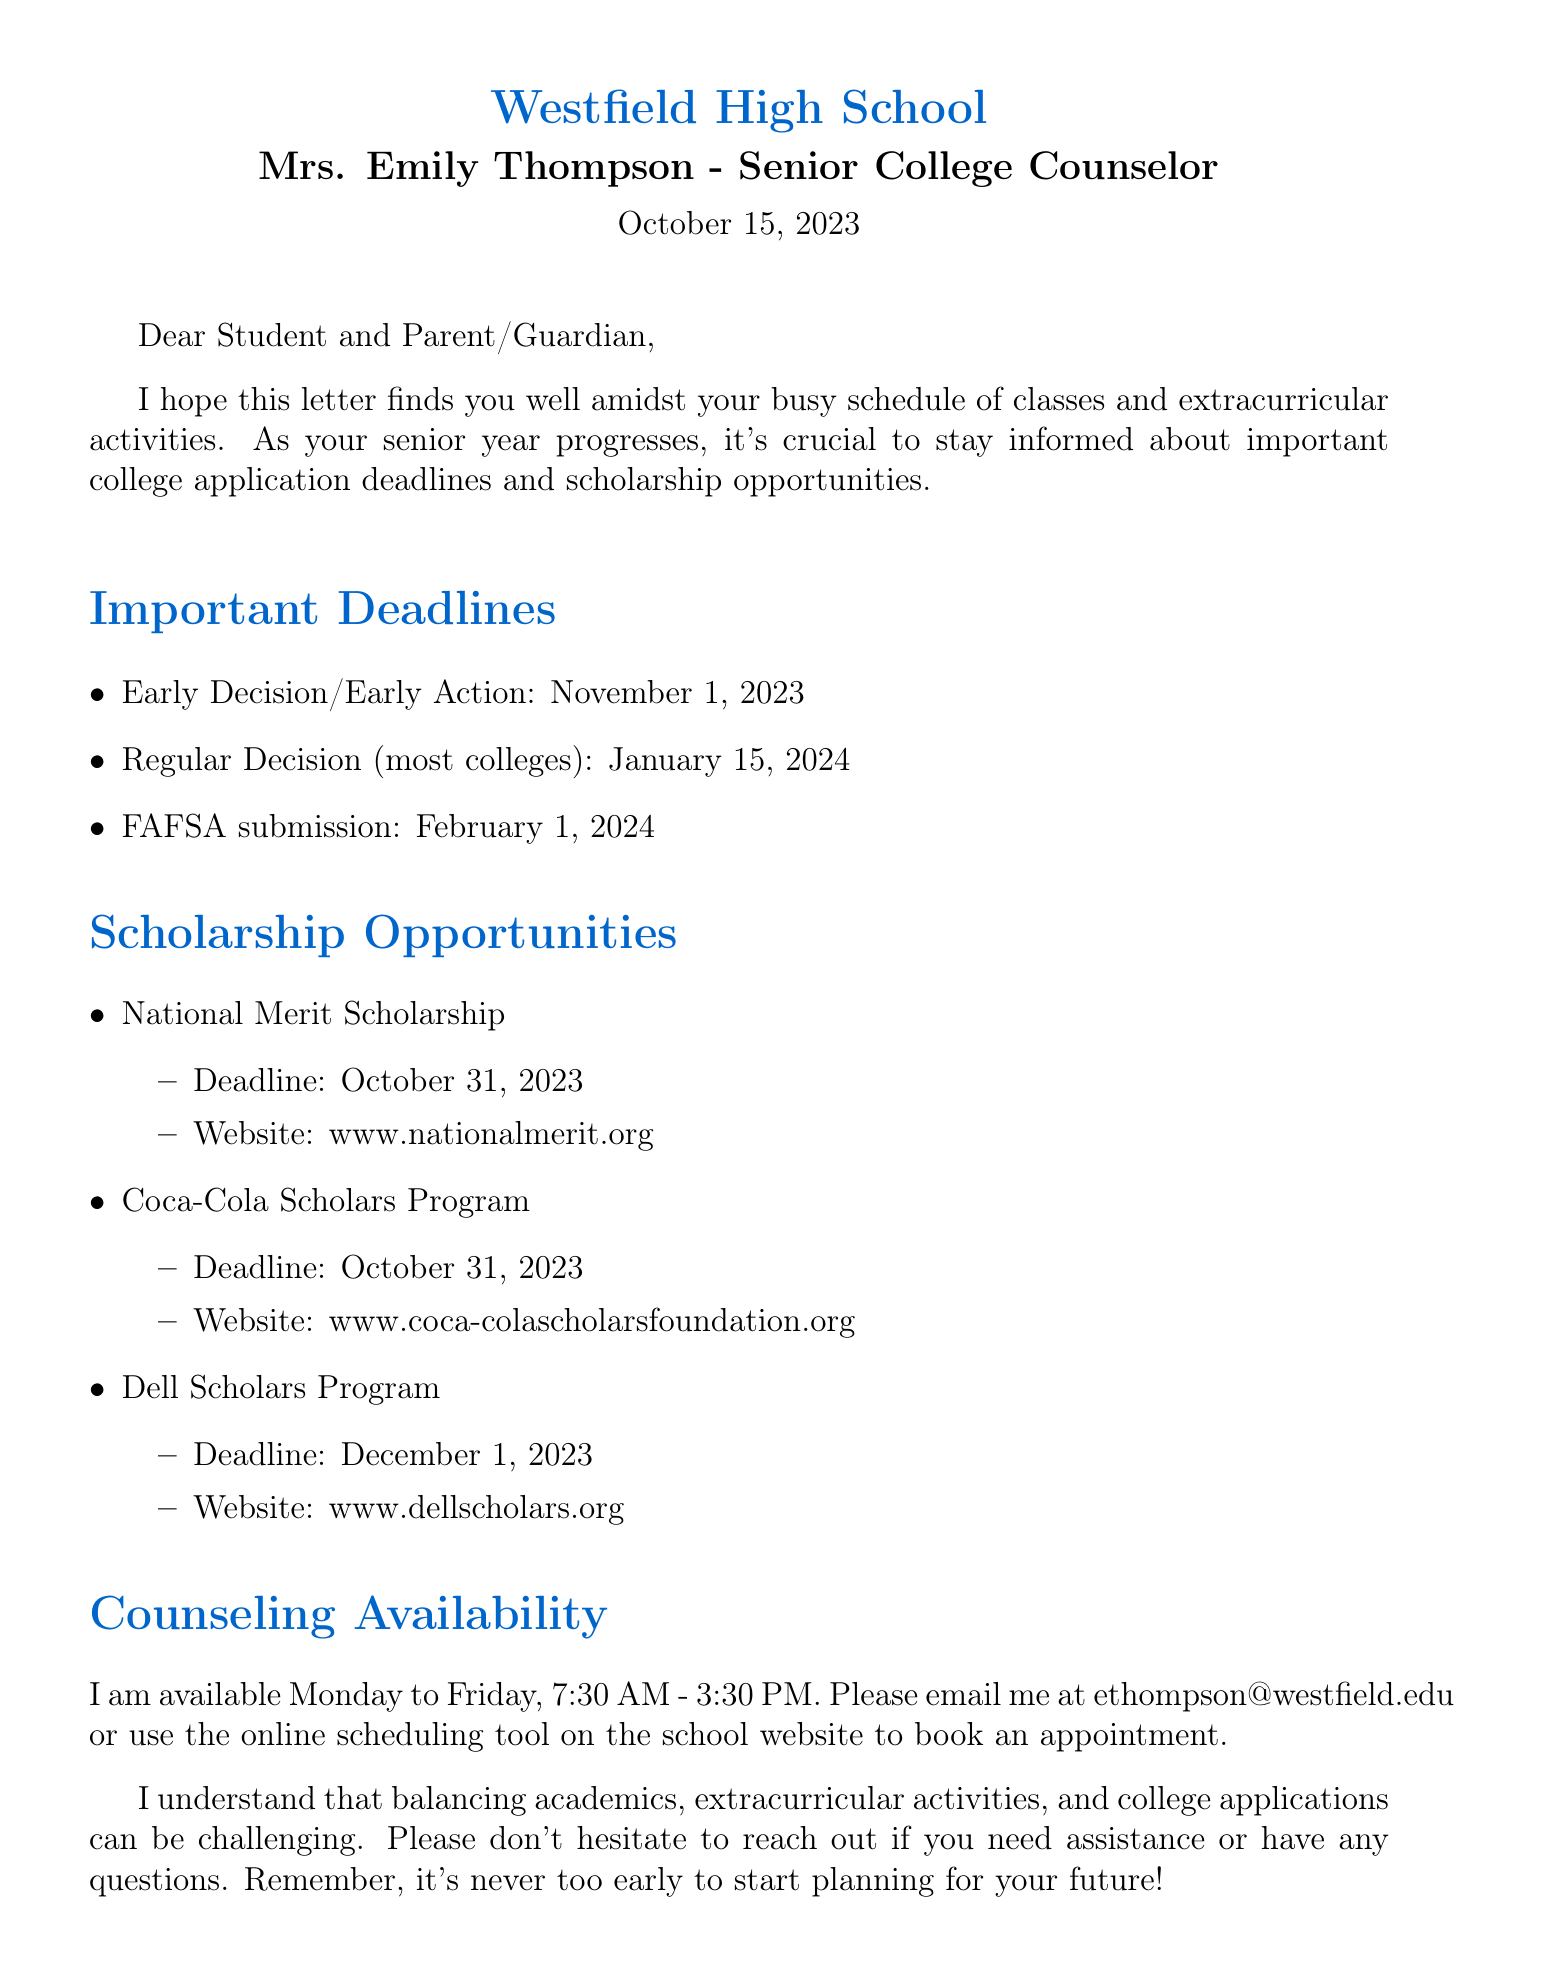What is the name of the school? The name of the school is mentioned at the beginning of the document.
Answer: Westfield High School Who is the senior college counselor? The document specifies the title and name of the counselor.
Answer: Mrs. Emily Thompson What is the deadline for Early Decision/Early Action applications? The document lists important deadlines for college applications.
Answer: November 1, 2023 When is the FAFSA submission deadline? The document provides the submission deadline for FAFSA.
Answer: February 1, 2024 What is the website for the National Merit Scholarship? The document includes specific scholarship opportunities and their details.
Answer: www.nationalmerit.org Why is it important to stay informed about deadlines? The introduction paragraph emphasizes the importance of deadlines in the context of college applications.
Answer: To stay informed about important college application deadlines and scholarship opportunities On which days is the counselor available? The document outlines the counselor's availability for appointments.
Answer: Monday to Friday How can students book an appointment with the counselor? The document provides instructions on how to contact the counselor for an appointment.
Answer: Email or online scheduling tool 